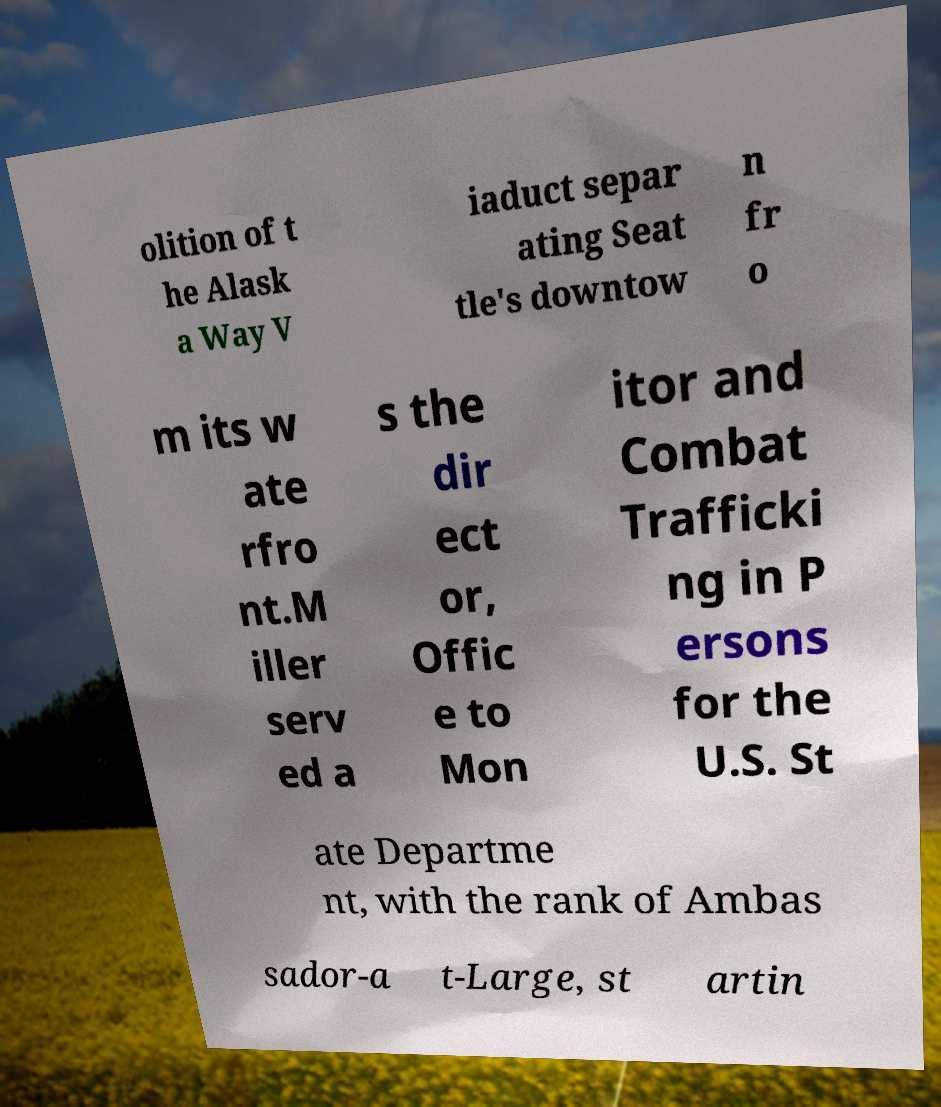Could you extract and type out the text from this image? olition of t he Alask a Way V iaduct separ ating Seat tle's downtow n fr o m its w ate rfro nt.M iller serv ed a s the dir ect or, Offic e to Mon itor and Combat Trafficki ng in P ersons for the U.S. St ate Departme nt, with the rank of Ambas sador-a t-Large, st artin 